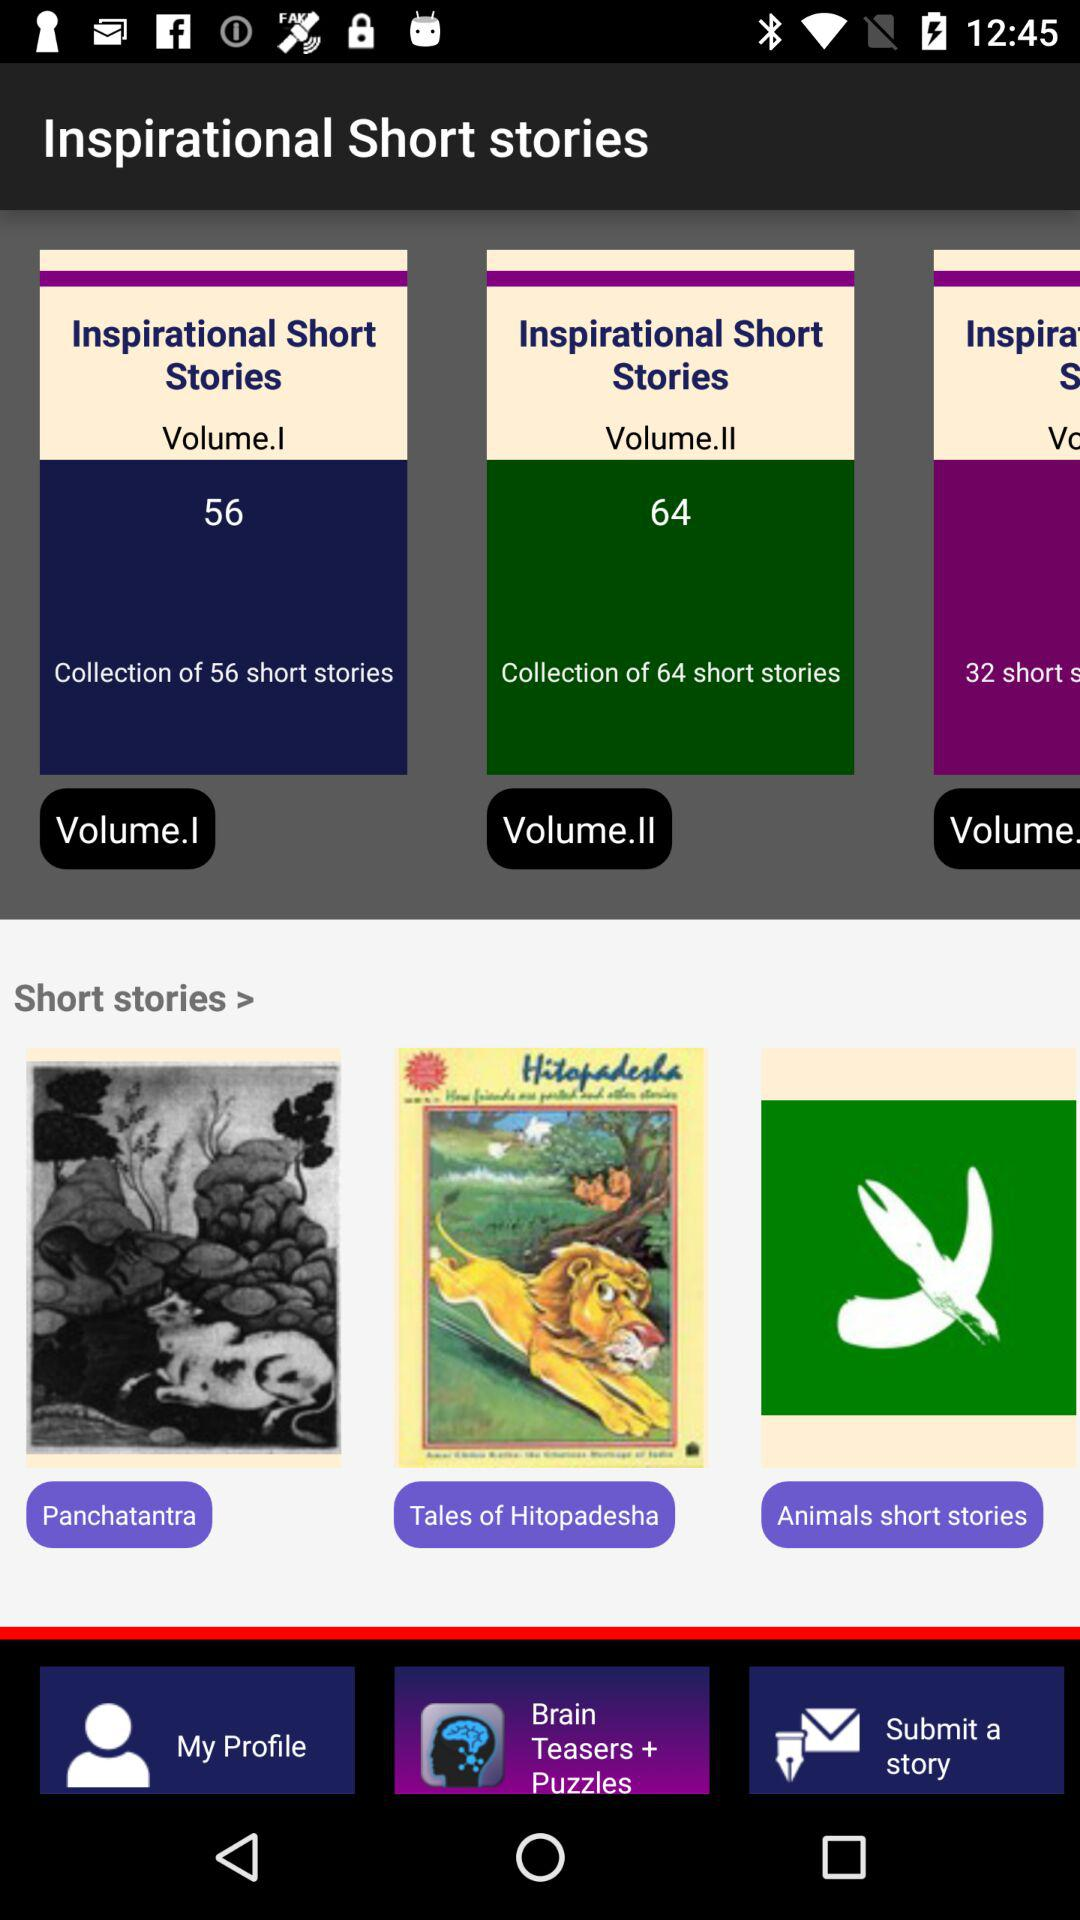What types of short stories are there? The type of short stories are "Panchatantra", "Tales of Hitopadesha" and "Animals short stories". 